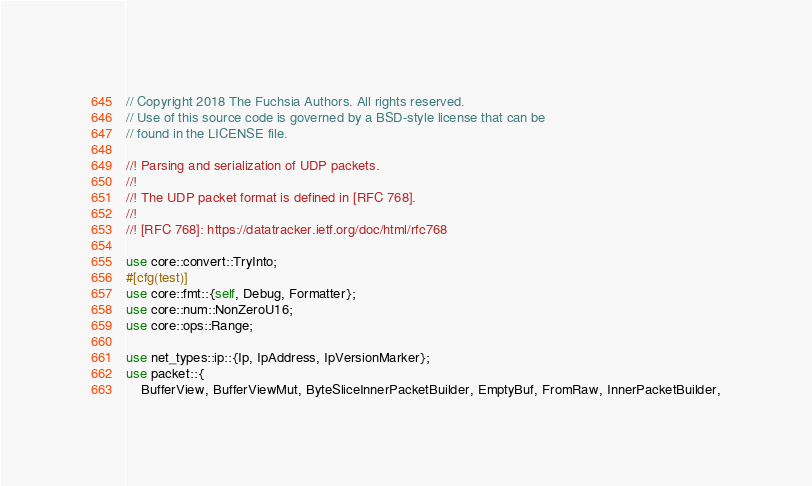Convert code to text. <code><loc_0><loc_0><loc_500><loc_500><_Rust_>// Copyright 2018 The Fuchsia Authors. All rights reserved.
// Use of this source code is governed by a BSD-style license that can be
// found in the LICENSE file.

//! Parsing and serialization of UDP packets.
//!
//! The UDP packet format is defined in [RFC 768].
//!
//! [RFC 768]: https://datatracker.ietf.org/doc/html/rfc768

use core::convert::TryInto;
#[cfg(test)]
use core::fmt::{self, Debug, Formatter};
use core::num::NonZeroU16;
use core::ops::Range;

use net_types::ip::{Ip, IpAddress, IpVersionMarker};
use packet::{
    BufferView, BufferViewMut, ByteSliceInnerPacketBuilder, EmptyBuf, FromRaw, InnerPacketBuilder,</code> 